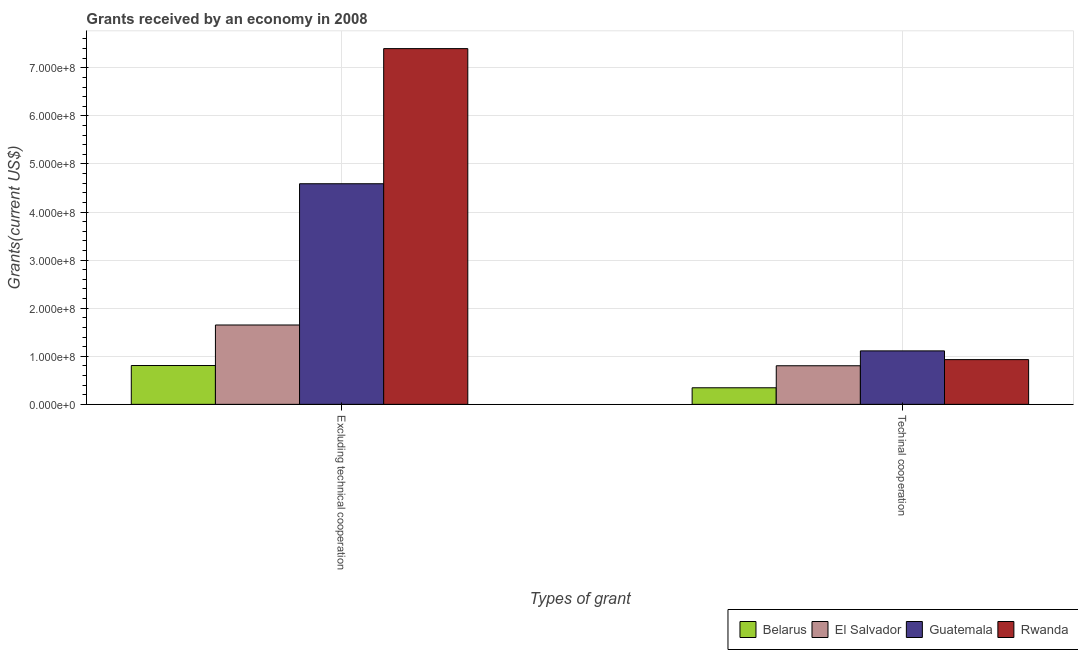How many different coloured bars are there?
Offer a terse response. 4. How many groups of bars are there?
Offer a terse response. 2. How many bars are there on the 1st tick from the left?
Make the answer very short. 4. How many bars are there on the 2nd tick from the right?
Provide a succinct answer. 4. What is the label of the 1st group of bars from the left?
Ensure brevity in your answer.  Excluding technical cooperation. What is the amount of grants received(including technical cooperation) in Belarus?
Your answer should be very brief. 3.45e+07. Across all countries, what is the maximum amount of grants received(including technical cooperation)?
Your answer should be very brief. 1.11e+08. Across all countries, what is the minimum amount of grants received(excluding technical cooperation)?
Give a very brief answer. 8.08e+07. In which country was the amount of grants received(including technical cooperation) maximum?
Ensure brevity in your answer.  Guatemala. In which country was the amount of grants received(excluding technical cooperation) minimum?
Make the answer very short. Belarus. What is the total amount of grants received(including technical cooperation) in the graph?
Make the answer very short. 3.19e+08. What is the difference between the amount of grants received(including technical cooperation) in El Salvador and that in Guatemala?
Offer a very short reply. -3.10e+07. What is the difference between the amount of grants received(excluding technical cooperation) in Belarus and the amount of grants received(including technical cooperation) in Guatemala?
Offer a very short reply. -3.04e+07. What is the average amount of grants received(including technical cooperation) per country?
Keep it short and to the point. 7.98e+07. What is the difference between the amount of grants received(excluding technical cooperation) and amount of grants received(including technical cooperation) in Guatemala?
Provide a succinct answer. 3.48e+08. What is the ratio of the amount of grants received(excluding technical cooperation) in Belarus to that in Rwanda?
Your response must be concise. 0.11. Is the amount of grants received(excluding technical cooperation) in El Salvador less than that in Belarus?
Your answer should be very brief. No. In how many countries, is the amount of grants received(including technical cooperation) greater than the average amount of grants received(including technical cooperation) taken over all countries?
Ensure brevity in your answer.  3. What does the 4th bar from the left in Excluding technical cooperation represents?
Provide a short and direct response. Rwanda. What does the 4th bar from the right in Excluding technical cooperation represents?
Provide a succinct answer. Belarus. Are all the bars in the graph horizontal?
Make the answer very short. No. How are the legend labels stacked?
Offer a terse response. Horizontal. What is the title of the graph?
Provide a short and direct response. Grants received by an economy in 2008. Does "Ireland" appear as one of the legend labels in the graph?
Provide a short and direct response. No. What is the label or title of the X-axis?
Provide a short and direct response. Types of grant. What is the label or title of the Y-axis?
Your answer should be compact. Grants(current US$). What is the Grants(current US$) of Belarus in Excluding technical cooperation?
Make the answer very short. 8.08e+07. What is the Grants(current US$) in El Salvador in Excluding technical cooperation?
Ensure brevity in your answer.  1.65e+08. What is the Grants(current US$) of Guatemala in Excluding technical cooperation?
Your response must be concise. 4.59e+08. What is the Grants(current US$) of Rwanda in Excluding technical cooperation?
Ensure brevity in your answer.  7.40e+08. What is the Grants(current US$) of Belarus in Techinal cooperation?
Keep it short and to the point. 3.45e+07. What is the Grants(current US$) of El Salvador in Techinal cooperation?
Your answer should be very brief. 8.03e+07. What is the Grants(current US$) in Guatemala in Techinal cooperation?
Ensure brevity in your answer.  1.11e+08. What is the Grants(current US$) of Rwanda in Techinal cooperation?
Offer a terse response. 9.31e+07. Across all Types of grant, what is the maximum Grants(current US$) of Belarus?
Make the answer very short. 8.08e+07. Across all Types of grant, what is the maximum Grants(current US$) of El Salvador?
Provide a succinct answer. 1.65e+08. Across all Types of grant, what is the maximum Grants(current US$) of Guatemala?
Offer a very short reply. 4.59e+08. Across all Types of grant, what is the maximum Grants(current US$) in Rwanda?
Provide a short and direct response. 7.40e+08. Across all Types of grant, what is the minimum Grants(current US$) in Belarus?
Offer a terse response. 3.45e+07. Across all Types of grant, what is the minimum Grants(current US$) in El Salvador?
Keep it short and to the point. 8.03e+07. Across all Types of grant, what is the minimum Grants(current US$) in Guatemala?
Offer a very short reply. 1.11e+08. Across all Types of grant, what is the minimum Grants(current US$) in Rwanda?
Your answer should be very brief. 9.31e+07. What is the total Grants(current US$) in Belarus in the graph?
Offer a very short reply. 1.15e+08. What is the total Grants(current US$) in El Salvador in the graph?
Keep it short and to the point. 2.45e+08. What is the total Grants(current US$) of Guatemala in the graph?
Give a very brief answer. 5.70e+08. What is the total Grants(current US$) of Rwanda in the graph?
Provide a succinct answer. 8.33e+08. What is the difference between the Grants(current US$) of Belarus in Excluding technical cooperation and that in Techinal cooperation?
Your answer should be very brief. 4.63e+07. What is the difference between the Grants(current US$) in El Salvador in Excluding technical cooperation and that in Techinal cooperation?
Your response must be concise. 8.48e+07. What is the difference between the Grants(current US$) of Guatemala in Excluding technical cooperation and that in Techinal cooperation?
Your response must be concise. 3.48e+08. What is the difference between the Grants(current US$) of Rwanda in Excluding technical cooperation and that in Techinal cooperation?
Offer a terse response. 6.47e+08. What is the difference between the Grants(current US$) of Belarus in Excluding technical cooperation and the Grants(current US$) of El Salvador in Techinal cooperation?
Offer a very short reply. 5.00e+05. What is the difference between the Grants(current US$) of Belarus in Excluding technical cooperation and the Grants(current US$) of Guatemala in Techinal cooperation?
Your answer should be compact. -3.04e+07. What is the difference between the Grants(current US$) in Belarus in Excluding technical cooperation and the Grants(current US$) in Rwanda in Techinal cooperation?
Offer a very short reply. -1.23e+07. What is the difference between the Grants(current US$) of El Salvador in Excluding technical cooperation and the Grants(current US$) of Guatemala in Techinal cooperation?
Make the answer very short. 5.38e+07. What is the difference between the Grants(current US$) of El Salvador in Excluding technical cooperation and the Grants(current US$) of Rwanda in Techinal cooperation?
Keep it short and to the point. 7.20e+07. What is the difference between the Grants(current US$) of Guatemala in Excluding technical cooperation and the Grants(current US$) of Rwanda in Techinal cooperation?
Ensure brevity in your answer.  3.66e+08. What is the average Grants(current US$) in Belarus per Types of grant?
Your response must be concise. 5.76e+07. What is the average Grants(current US$) of El Salvador per Types of grant?
Provide a short and direct response. 1.23e+08. What is the average Grants(current US$) in Guatemala per Types of grant?
Give a very brief answer. 2.85e+08. What is the average Grants(current US$) in Rwanda per Types of grant?
Give a very brief answer. 4.16e+08. What is the difference between the Grants(current US$) of Belarus and Grants(current US$) of El Salvador in Excluding technical cooperation?
Provide a short and direct response. -8.43e+07. What is the difference between the Grants(current US$) of Belarus and Grants(current US$) of Guatemala in Excluding technical cooperation?
Give a very brief answer. -3.78e+08. What is the difference between the Grants(current US$) of Belarus and Grants(current US$) of Rwanda in Excluding technical cooperation?
Your answer should be very brief. -6.59e+08. What is the difference between the Grants(current US$) in El Salvador and Grants(current US$) in Guatemala in Excluding technical cooperation?
Make the answer very short. -2.94e+08. What is the difference between the Grants(current US$) in El Salvador and Grants(current US$) in Rwanda in Excluding technical cooperation?
Your response must be concise. -5.75e+08. What is the difference between the Grants(current US$) of Guatemala and Grants(current US$) of Rwanda in Excluding technical cooperation?
Provide a succinct answer. -2.81e+08. What is the difference between the Grants(current US$) in Belarus and Grants(current US$) in El Salvador in Techinal cooperation?
Provide a short and direct response. -4.58e+07. What is the difference between the Grants(current US$) in Belarus and Grants(current US$) in Guatemala in Techinal cooperation?
Keep it short and to the point. -7.68e+07. What is the difference between the Grants(current US$) of Belarus and Grants(current US$) of Rwanda in Techinal cooperation?
Make the answer very short. -5.86e+07. What is the difference between the Grants(current US$) in El Salvador and Grants(current US$) in Guatemala in Techinal cooperation?
Ensure brevity in your answer.  -3.10e+07. What is the difference between the Grants(current US$) of El Salvador and Grants(current US$) of Rwanda in Techinal cooperation?
Offer a very short reply. -1.28e+07. What is the difference between the Grants(current US$) in Guatemala and Grants(current US$) in Rwanda in Techinal cooperation?
Give a very brief answer. 1.82e+07. What is the ratio of the Grants(current US$) in Belarus in Excluding technical cooperation to that in Techinal cooperation?
Offer a very short reply. 2.34. What is the ratio of the Grants(current US$) of El Salvador in Excluding technical cooperation to that in Techinal cooperation?
Your answer should be compact. 2.06. What is the ratio of the Grants(current US$) of Guatemala in Excluding technical cooperation to that in Techinal cooperation?
Provide a succinct answer. 4.13. What is the ratio of the Grants(current US$) of Rwanda in Excluding technical cooperation to that in Techinal cooperation?
Your response must be concise. 7.95. What is the difference between the highest and the second highest Grants(current US$) of Belarus?
Keep it short and to the point. 4.63e+07. What is the difference between the highest and the second highest Grants(current US$) in El Salvador?
Provide a succinct answer. 8.48e+07. What is the difference between the highest and the second highest Grants(current US$) of Guatemala?
Keep it short and to the point. 3.48e+08. What is the difference between the highest and the second highest Grants(current US$) in Rwanda?
Make the answer very short. 6.47e+08. What is the difference between the highest and the lowest Grants(current US$) of Belarus?
Your response must be concise. 4.63e+07. What is the difference between the highest and the lowest Grants(current US$) in El Salvador?
Provide a short and direct response. 8.48e+07. What is the difference between the highest and the lowest Grants(current US$) in Guatemala?
Provide a short and direct response. 3.48e+08. What is the difference between the highest and the lowest Grants(current US$) of Rwanda?
Keep it short and to the point. 6.47e+08. 